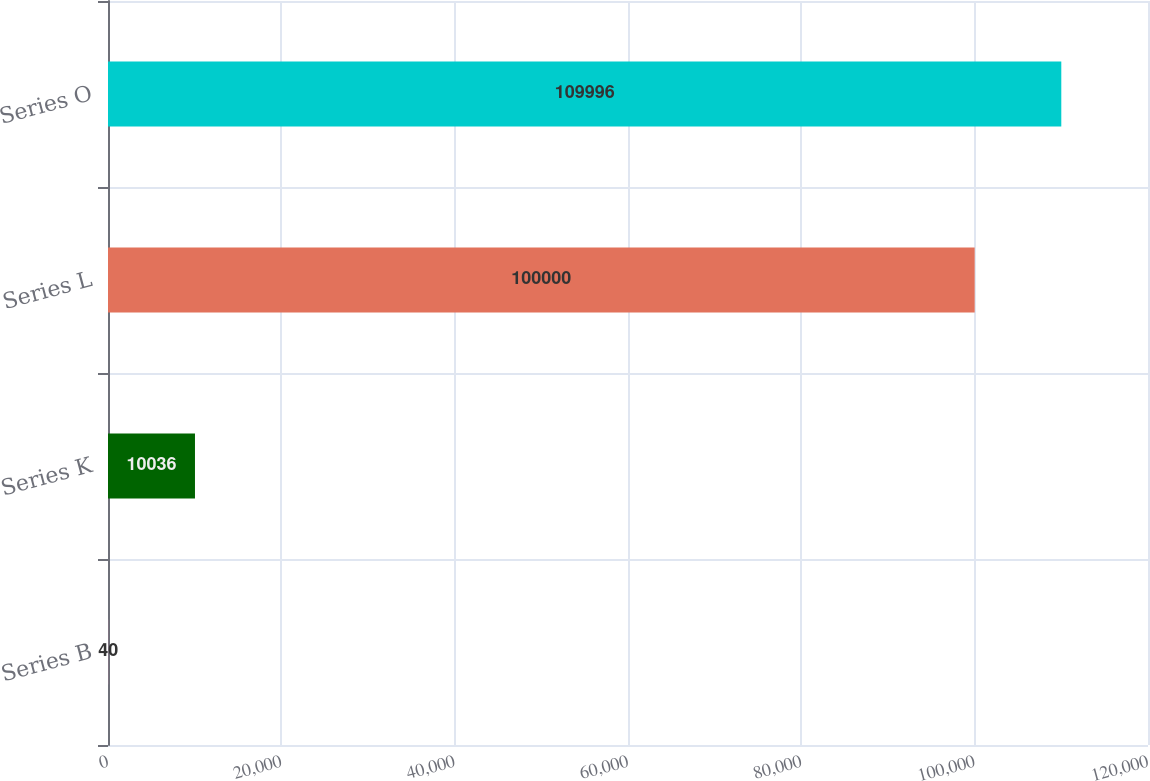<chart> <loc_0><loc_0><loc_500><loc_500><bar_chart><fcel>Series B<fcel>Series K<fcel>Series L<fcel>Series O<nl><fcel>40<fcel>10036<fcel>100000<fcel>109996<nl></chart> 